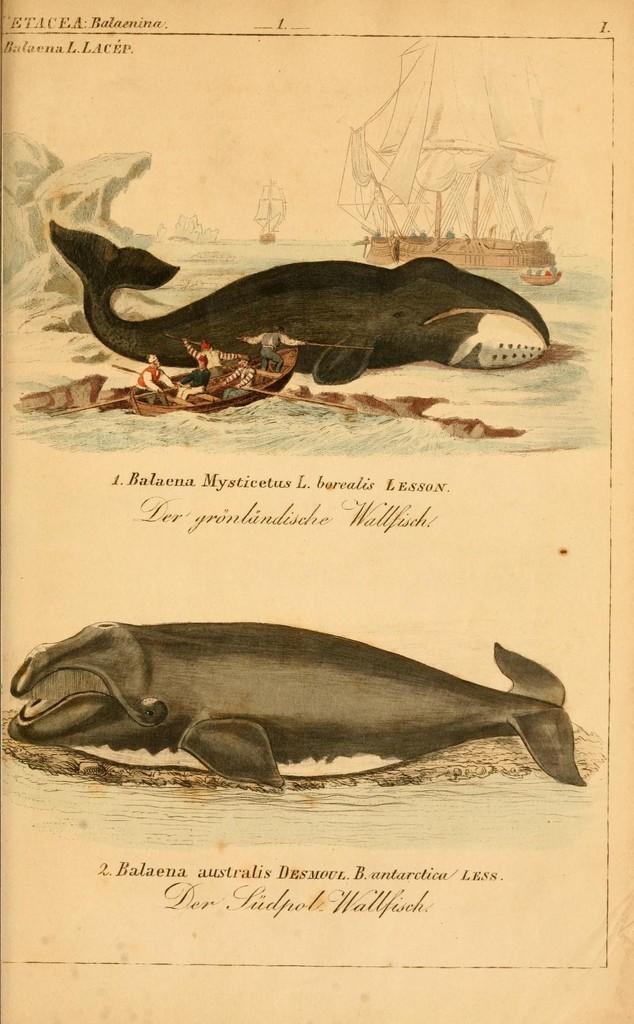How would you summarize this image in a sentence or two? It is a paper, there are images of two whales on it and few persons are rowing the boat, on the right side there is a ship in the water. 